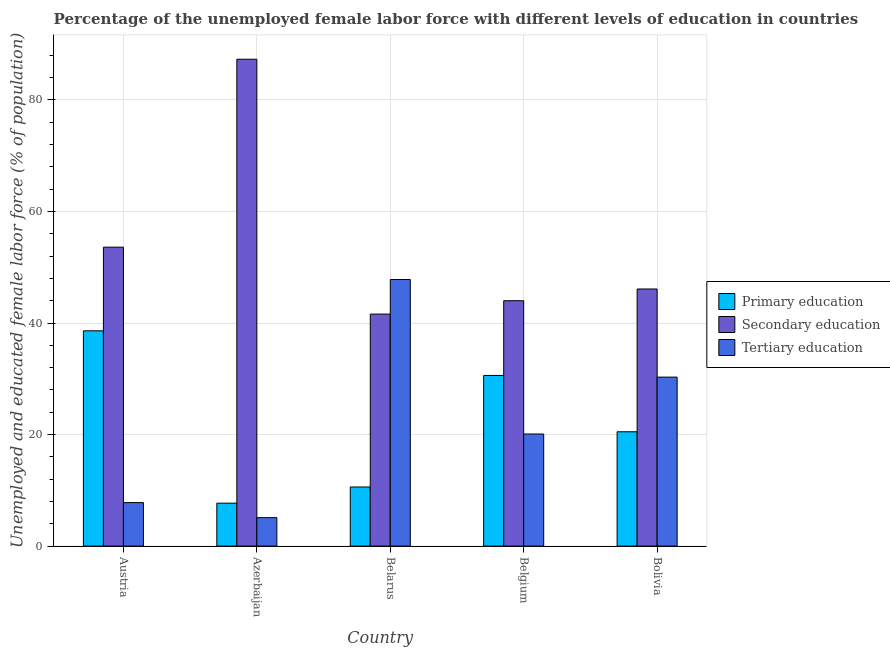How many groups of bars are there?
Your response must be concise. 5. Are the number of bars on each tick of the X-axis equal?
Offer a terse response. Yes. How many bars are there on the 5th tick from the left?
Your answer should be compact. 3. What is the label of the 2nd group of bars from the left?
Your response must be concise. Azerbaijan. What is the percentage of female labor force who received tertiary education in Azerbaijan?
Your response must be concise. 5.1. Across all countries, what is the maximum percentage of female labor force who received tertiary education?
Offer a very short reply. 47.8. Across all countries, what is the minimum percentage of female labor force who received secondary education?
Offer a very short reply. 41.6. In which country was the percentage of female labor force who received secondary education maximum?
Provide a succinct answer. Azerbaijan. In which country was the percentage of female labor force who received tertiary education minimum?
Your response must be concise. Azerbaijan. What is the total percentage of female labor force who received primary education in the graph?
Offer a very short reply. 108. What is the difference between the percentage of female labor force who received primary education in Belarus and that in Belgium?
Make the answer very short. -20. What is the difference between the percentage of female labor force who received secondary education in Belarus and the percentage of female labor force who received primary education in Belgium?
Offer a very short reply. 11. What is the average percentage of female labor force who received tertiary education per country?
Give a very brief answer. 22.22. What is the difference between the percentage of female labor force who received tertiary education and percentage of female labor force who received primary education in Bolivia?
Your answer should be compact. 9.8. In how many countries, is the percentage of female labor force who received tertiary education greater than 72 %?
Your answer should be compact. 0. What is the ratio of the percentage of female labor force who received secondary education in Belgium to that in Bolivia?
Make the answer very short. 0.95. Is the percentage of female labor force who received secondary education in Azerbaijan less than that in Bolivia?
Make the answer very short. No. What is the difference between the highest and the second highest percentage of female labor force who received tertiary education?
Your response must be concise. 17.5. What is the difference between the highest and the lowest percentage of female labor force who received secondary education?
Your answer should be very brief. 45.7. Is the sum of the percentage of female labor force who received primary education in Azerbaijan and Belgium greater than the maximum percentage of female labor force who received secondary education across all countries?
Your answer should be very brief. No. What does the 3rd bar from the left in Belarus represents?
Give a very brief answer. Tertiary education. What does the 2nd bar from the right in Azerbaijan represents?
Offer a terse response. Secondary education. How many bars are there?
Ensure brevity in your answer.  15. Does the graph contain any zero values?
Ensure brevity in your answer.  No. Does the graph contain grids?
Your response must be concise. Yes. Where does the legend appear in the graph?
Offer a terse response. Center right. How many legend labels are there?
Keep it short and to the point. 3. What is the title of the graph?
Make the answer very short. Percentage of the unemployed female labor force with different levels of education in countries. Does "Oil sources" appear as one of the legend labels in the graph?
Provide a succinct answer. No. What is the label or title of the X-axis?
Keep it short and to the point. Country. What is the label or title of the Y-axis?
Offer a terse response. Unemployed and educated female labor force (% of population). What is the Unemployed and educated female labor force (% of population) of Primary education in Austria?
Keep it short and to the point. 38.6. What is the Unemployed and educated female labor force (% of population) in Secondary education in Austria?
Ensure brevity in your answer.  53.6. What is the Unemployed and educated female labor force (% of population) of Tertiary education in Austria?
Your answer should be compact. 7.8. What is the Unemployed and educated female labor force (% of population) in Primary education in Azerbaijan?
Your answer should be compact. 7.7. What is the Unemployed and educated female labor force (% of population) of Secondary education in Azerbaijan?
Provide a short and direct response. 87.3. What is the Unemployed and educated female labor force (% of population) of Tertiary education in Azerbaijan?
Give a very brief answer. 5.1. What is the Unemployed and educated female labor force (% of population) of Primary education in Belarus?
Your response must be concise. 10.6. What is the Unemployed and educated female labor force (% of population) in Secondary education in Belarus?
Ensure brevity in your answer.  41.6. What is the Unemployed and educated female labor force (% of population) in Tertiary education in Belarus?
Provide a succinct answer. 47.8. What is the Unemployed and educated female labor force (% of population) of Primary education in Belgium?
Your answer should be compact. 30.6. What is the Unemployed and educated female labor force (% of population) of Tertiary education in Belgium?
Your answer should be very brief. 20.1. What is the Unemployed and educated female labor force (% of population) of Secondary education in Bolivia?
Offer a terse response. 46.1. What is the Unemployed and educated female labor force (% of population) of Tertiary education in Bolivia?
Provide a succinct answer. 30.3. Across all countries, what is the maximum Unemployed and educated female labor force (% of population) of Primary education?
Offer a very short reply. 38.6. Across all countries, what is the maximum Unemployed and educated female labor force (% of population) of Secondary education?
Keep it short and to the point. 87.3. Across all countries, what is the maximum Unemployed and educated female labor force (% of population) of Tertiary education?
Provide a short and direct response. 47.8. Across all countries, what is the minimum Unemployed and educated female labor force (% of population) in Primary education?
Keep it short and to the point. 7.7. Across all countries, what is the minimum Unemployed and educated female labor force (% of population) in Secondary education?
Ensure brevity in your answer.  41.6. Across all countries, what is the minimum Unemployed and educated female labor force (% of population) in Tertiary education?
Make the answer very short. 5.1. What is the total Unemployed and educated female labor force (% of population) of Primary education in the graph?
Provide a succinct answer. 108. What is the total Unemployed and educated female labor force (% of population) of Secondary education in the graph?
Provide a succinct answer. 272.6. What is the total Unemployed and educated female labor force (% of population) in Tertiary education in the graph?
Your answer should be compact. 111.1. What is the difference between the Unemployed and educated female labor force (% of population) in Primary education in Austria and that in Azerbaijan?
Your answer should be compact. 30.9. What is the difference between the Unemployed and educated female labor force (% of population) of Secondary education in Austria and that in Azerbaijan?
Provide a short and direct response. -33.7. What is the difference between the Unemployed and educated female labor force (% of population) of Primary education in Austria and that in Belgium?
Your response must be concise. 8. What is the difference between the Unemployed and educated female labor force (% of population) in Secondary education in Austria and that in Belgium?
Keep it short and to the point. 9.6. What is the difference between the Unemployed and educated female labor force (% of population) in Tertiary education in Austria and that in Bolivia?
Provide a succinct answer. -22.5. What is the difference between the Unemployed and educated female labor force (% of population) of Primary education in Azerbaijan and that in Belarus?
Your answer should be very brief. -2.9. What is the difference between the Unemployed and educated female labor force (% of population) of Secondary education in Azerbaijan and that in Belarus?
Offer a terse response. 45.7. What is the difference between the Unemployed and educated female labor force (% of population) in Tertiary education in Azerbaijan and that in Belarus?
Make the answer very short. -42.7. What is the difference between the Unemployed and educated female labor force (% of population) of Primary education in Azerbaijan and that in Belgium?
Offer a terse response. -22.9. What is the difference between the Unemployed and educated female labor force (% of population) of Secondary education in Azerbaijan and that in Belgium?
Keep it short and to the point. 43.3. What is the difference between the Unemployed and educated female labor force (% of population) in Tertiary education in Azerbaijan and that in Belgium?
Offer a very short reply. -15. What is the difference between the Unemployed and educated female labor force (% of population) of Secondary education in Azerbaijan and that in Bolivia?
Your answer should be compact. 41.2. What is the difference between the Unemployed and educated female labor force (% of population) in Tertiary education in Azerbaijan and that in Bolivia?
Your answer should be compact. -25.2. What is the difference between the Unemployed and educated female labor force (% of population) of Tertiary education in Belarus and that in Belgium?
Ensure brevity in your answer.  27.7. What is the difference between the Unemployed and educated female labor force (% of population) of Secondary education in Belarus and that in Bolivia?
Your answer should be very brief. -4.5. What is the difference between the Unemployed and educated female labor force (% of population) in Tertiary education in Belarus and that in Bolivia?
Offer a terse response. 17.5. What is the difference between the Unemployed and educated female labor force (% of population) of Primary education in Belgium and that in Bolivia?
Provide a succinct answer. 10.1. What is the difference between the Unemployed and educated female labor force (% of population) of Secondary education in Belgium and that in Bolivia?
Provide a short and direct response. -2.1. What is the difference between the Unemployed and educated female labor force (% of population) in Tertiary education in Belgium and that in Bolivia?
Your answer should be very brief. -10.2. What is the difference between the Unemployed and educated female labor force (% of population) in Primary education in Austria and the Unemployed and educated female labor force (% of population) in Secondary education in Azerbaijan?
Your answer should be very brief. -48.7. What is the difference between the Unemployed and educated female labor force (% of population) of Primary education in Austria and the Unemployed and educated female labor force (% of population) of Tertiary education in Azerbaijan?
Give a very brief answer. 33.5. What is the difference between the Unemployed and educated female labor force (% of population) of Secondary education in Austria and the Unemployed and educated female labor force (% of population) of Tertiary education in Azerbaijan?
Make the answer very short. 48.5. What is the difference between the Unemployed and educated female labor force (% of population) of Primary education in Austria and the Unemployed and educated female labor force (% of population) of Secondary education in Belgium?
Provide a succinct answer. -5.4. What is the difference between the Unemployed and educated female labor force (% of population) in Secondary education in Austria and the Unemployed and educated female labor force (% of population) in Tertiary education in Belgium?
Offer a very short reply. 33.5. What is the difference between the Unemployed and educated female labor force (% of population) in Primary education in Austria and the Unemployed and educated female labor force (% of population) in Secondary education in Bolivia?
Give a very brief answer. -7.5. What is the difference between the Unemployed and educated female labor force (% of population) in Secondary education in Austria and the Unemployed and educated female labor force (% of population) in Tertiary education in Bolivia?
Keep it short and to the point. 23.3. What is the difference between the Unemployed and educated female labor force (% of population) in Primary education in Azerbaijan and the Unemployed and educated female labor force (% of population) in Secondary education in Belarus?
Provide a succinct answer. -33.9. What is the difference between the Unemployed and educated female labor force (% of population) of Primary education in Azerbaijan and the Unemployed and educated female labor force (% of population) of Tertiary education in Belarus?
Offer a terse response. -40.1. What is the difference between the Unemployed and educated female labor force (% of population) in Secondary education in Azerbaijan and the Unemployed and educated female labor force (% of population) in Tertiary education in Belarus?
Provide a succinct answer. 39.5. What is the difference between the Unemployed and educated female labor force (% of population) of Primary education in Azerbaijan and the Unemployed and educated female labor force (% of population) of Secondary education in Belgium?
Your answer should be very brief. -36.3. What is the difference between the Unemployed and educated female labor force (% of population) of Primary education in Azerbaijan and the Unemployed and educated female labor force (% of population) of Tertiary education in Belgium?
Ensure brevity in your answer.  -12.4. What is the difference between the Unemployed and educated female labor force (% of population) of Secondary education in Azerbaijan and the Unemployed and educated female labor force (% of population) of Tertiary education in Belgium?
Offer a terse response. 67.2. What is the difference between the Unemployed and educated female labor force (% of population) in Primary education in Azerbaijan and the Unemployed and educated female labor force (% of population) in Secondary education in Bolivia?
Provide a succinct answer. -38.4. What is the difference between the Unemployed and educated female labor force (% of population) of Primary education in Azerbaijan and the Unemployed and educated female labor force (% of population) of Tertiary education in Bolivia?
Give a very brief answer. -22.6. What is the difference between the Unemployed and educated female labor force (% of population) of Primary education in Belarus and the Unemployed and educated female labor force (% of population) of Secondary education in Belgium?
Make the answer very short. -33.4. What is the difference between the Unemployed and educated female labor force (% of population) of Primary education in Belarus and the Unemployed and educated female labor force (% of population) of Tertiary education in Belgium?
Give a very brief answer. -9.5. What is the difference between the Unemployed and educated female labor force (% of population) of Secondary education in Belarus and the Unemployed and educated female labor force (% of population) of Tertiary education in Belgium?
Offer a very short reply. 21.5. What is the difference between the Unemployed and educated female labor force (% of population) in Primary education in Belarus and the Unemployed and educated female labor force (% of population) in Secondary education in Bolivia?
Ensure brevity in your answer.  -35.5. What is the difference between the Unemployed and educated female labor force (% of population) in Primary education in Belarus and the Unemployed and educated female labor force (% of population) in Tertiary education in Bolivia?
Your answer should be compact. -19.7. What is the difference between the Unemployed and educated female labor force (% of population) in Primary education in Belgium and the Unemployed and educated female labor force (% of population) in Secondary education in Bolivia?
Offer a terse response. -15.5. What is the difference between the Unemployed and educated female labor force (% of population) of Secondary education in Belgium and the Unemployed and educated female labor force (% of population) of Tertiary education in Bolivia?
Give a very brief answer. 13.7. What is the average Unemployed and educated female labor force (% of population) of Primary education per country?
Ensure brevity in your answer.  21.6. What is the average Unemployed and educated female labor force (% of population) in Secondary education per country?
Your response must be concise. 54.52. What is the average Unemployed and educated female labor force (% of population) in Tertiary education per country?
Your answer should be very brief. 22.22. What is the difference between the Unemployed and educated female labor force (% of population) of Primary education and Unemployed and educated female labor force (% of population) of Secondary education in Austria?
Provide a succinct answer. -15. What is the difference between the Unemployed and educated female labor force (% of population) of Primary education and Unemployed and educated female labor force (% of population) of Tertiary education in Austria?
Ensure brevity in your answer.  30.8. What is the difference between the Unemployed and educated female labor force (% of population) of Secondary education and Unemployed and educated female labor force (% of population) of Tertiary education in Austria?
Your answer should be very brief. 45.8. What is the difference between the Unemployed and educated female labor force (% of population) in Primary education and Unemployed and educated female labor force (% of population) in Secondary education in Azerbaijan?
Keep it short and to the point. -79.6. What is the difference between the Unemployed and educated female labor force (% of population) of Primary education and Unemployed and educated female labor force (% of population) of Tertiary education in Azerbaijan?
Ensure brevity in your answer.  2.6. What is the difference between the Unemployed and educated female labor force (% of population) of Secondary education and Unemployed and educated female labor force (% of population) of Tertiary education in Azerbaijan?
Provide a short and direct response. 82.2. What is the difference between the Unemployed and educated female labor force (% of population) of Primary education and Unemployed and educated female labor force (% of population) of Secondary education in Belarus?
Make the answer very short. -31. What is the difference between the Unemployed and educated female labor force (% of population) in Primary education and Unemployed and educated female labor force (% of population) in Tertiary education in Belarus?
Your answer should be compact. -37.2. What is the difference between the Unemployed and educated female labor force (% of population) in Primary education and Unemployed and educated female labor force (% of population) in Tertiary education in Belgium?
Offer a terse response. 10.5. What is the difference between the Unemployed and educated female labor force (% of population) of Secondary education and Unemployed and educated female labor force (% of population) of Tertiary education in Belgium?
Offer a terse response. 23.9. What is the difference between the Unemployed and educated female labor force (% of population) in Primary education and Unemployed and educated female labor force (% of population) in Secondary education in Bolivia?
Offer a very short reply. -25.6. What is the difference between the Unemployed and educated female labor force (% of population) of Secondary education and Unemployed and educated female labor force (% of population) of Tertiary education in Bolivia?
Provide a succinct answer. 15.8. What is the ratio of the Unemployed and educated female labor force (% of population) in Primary education in Austria to that in Azerbaijan?
Keep it short and to the point. 5.01. What is the ratio of the Unemployed and educated female labor force (% of population) in Secondary education in Austria to that in Azerbaijan?
Provide a short and direct response. 0.61. What is the ratio of the Unemployed and educated female labor force (% of population) in Tertiary education in Austria to that in Azerbaijan?
Ensure brevity in your answer.  1.53. What is the ratio of the Unemployed and educated female labor force (% of population) in Primary education in Austria to that in Belarus?
Keep it short and to the point. 3.64. What is the ratio of the Unemployed and educated female labor force (% of population) in Secondary education in Austria to that in Belarus?
Offer a terse response. 1.29. What is the ratio of the Unemployed and educated female labor force (% of population) of Tertiary education in Austria to that in Belarus?
Keep it short and to the point. 0.16. What is the ratio of the Unemployed and educated female labor force (% of population) of Primary education in Austria to that in Belgium?
Provide a succinct answer. 1.26. What is the ratio of the Unemployed and educated female labor force (% of population) of Secondary education in Austria to that in Belgium?
Your answer should be very brief. 1.22. What is the ratio of the Unemployed and educated female labor force (% of population) in Tertiary education in Austria to that in Belgium?
Your answer should be compact. 0.39. What is the ratio of the Unemployed and educated female labor force (% of population) in Primary education in Austria to that in Bolivia?
Provide a short and direct response. 1.88. What is the ratio of the Unemployed and educated female labor force (% of population) in Secondary education in Austria to that in Bolivia?
Your answer should be very brief. 1.16. What is the ratio of the Unemployed and educated female labor force (% of population) of Tertiary education in Austria to that in Bolivia?
Your answer should be very brief. 0.26. What is the ratio of the Unemployed and educated female labor force (% of population) in Primary education in Azerbaijan to that in Belarus?
Provide a short and direct response. 0.73. What is the ratio of the Unemployed and educated female labor force (% of population) of Secondary education in Azerbaijan to that in Belarus?
Make the answer very short. 2.1. What is the ratio of the Unemployed and educated female labor force (% of population) of Tertiary education in Azerbaijan to that in Belarus?
Your answer should be compact. 0.11. What is the ratio of the Unemployed and educated female labor force (% of population) of Primary education in Azerbaijan to that in Belgium?
Your answer should be compact. 0.25. What is the ratio of the Unemployed and educated female labor force (% of population) of Secondary education in Azerbaijan to that in Belgium?
Your answer should be compact. 1.98. What is the ratio of the Unemployed and educated female labor force (% of population) in Tertiary education in Azerbaijan to that in Belgium?
Your answer should be compact. 0.25. What is the ratio of the Unemployed and educated female labor force (% of population) in Primary education in Azerbaijan to that in Bolivia?
Your answer should be compact. 0.38. What is the ratio of the Unemployed and educated female labor force (% of population) of Secondary education in Azerbaijan to that in Bolivia?
Your answer should be very brief. 1.89. What is the ratio of the Unemployed and educated female labor force (% of population) of Tertiary education in Azerbaijan to that in Bolivia?
Ensure brevity in your answer.  0.17. What is the ratio of the Unemployed and educated female labor force (% of population) in Primary education in Belarus to that in Belgium?
Your response must be concise. 0.35. What is the ratio of the Unemployed and educated female labor force (% of population) of Secondary education in Belarus to that in Belgium?
Your response must be concise. 0.95. What is the ratio of the Unemployed and educated female labor force (% of population) in Tertiary education in Belarus to that in Belgium?
Your answer should be very brief. 2.38. What is the ratio of the Unemployed and educated female labor force (% of population) in Primary education in Belarus to that in Bolivia?
Offer a terse response. 0.52. What is the ratio of the Unemployed and educated female labor force (% of population) in Secondary education in Belarus to that in Bolivia?
Provide a succinct answer. 0.9. What is the ratio of the Unemployed and educated female labor force (% of population) of Tertiary education in Belarus to that in Bolivia?
Your response must be concise. 1.58. What is the ratio of the Unemployed and educated female labor force (% of population) of Primary education in Belgium to that in Bolivia?
Offer a terse response. 1.49. What is the ratio of the Unemployed and educated female labor force (% of population) in Secondary education in Belgium to that in Bolivia?
Your answer should be compact. 0.95. What is the ratio of the Unemployed and educated female labor force (% of population) in Tertiary education in Belgium to that in Bolivia?
Provide a succinct answer. 0.66. What is the difference between the highest and the second highest Unemployed and educated female labor force (% of population) in Primary education?
Ensure brevity in your answer.  8. What is the difference between the highest and the second highest Unemployed and educated female labor force (% of population) in Secondary education?
Make the answer very short. 33.7. What is the difference between the highest and the lowest Unemployed and educated female labor force (% of population) of Primary education?
Your answer should be very brief. 30.9. What is the difference between the highest and the lowest Unemployed and educated female labor force (% of population) in Secondary education?
Your response must be concise. 45.7. What is the difference between the highest and the lowest Unemployed and educated female labor force (% of population) of Tertiary education?
Provide a succinct answer. 42.7. 